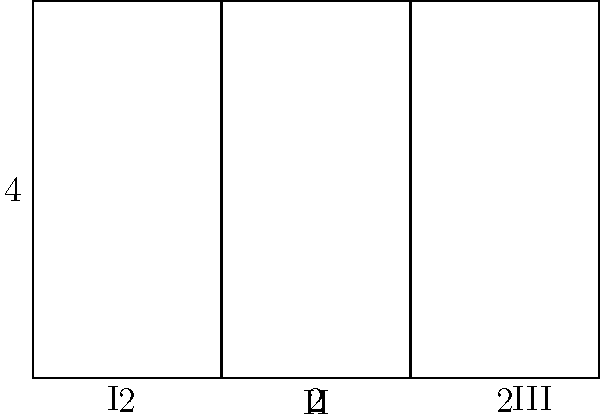Your room is shaped like a rectangle and has been divided into three sections as shown in the diagram. The total width of the room is 6 units, and the height is 4 units. Each section has a width of 2 units. What is the total area of sections I and III combined? Let's approach this step-by-step:

1) First, we need to calculate the area of each section separately.

2) The formula for the area of a rectangle is: $A = length \times width$

3) For section I:
   Length = 4 units
   Width = 2 units
   Area of I = $4 \times 2 = 8$ square units

4) For section III:
   Length = 4 units
   Width = 2 units
   Area of III = $4 \times 2 = 8$ square units

5) Now, we need to add the areas of sections I and III:
   Total Area = Area of I + Area of III
               = $8 + 8 = 16$ square units

Therefore, the total area of sections I and III combined is 16 square units.
Answer: 16 square units 